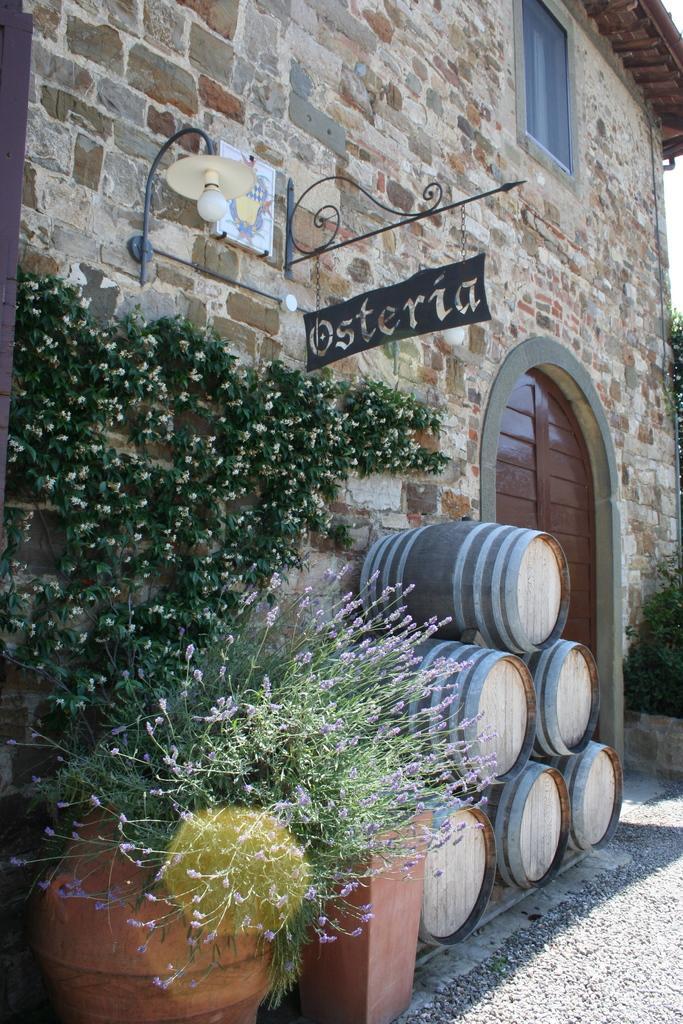In one or two sentences, can you explain what this image depicts? As we can see in the image there is a building, light, drums and plants. 